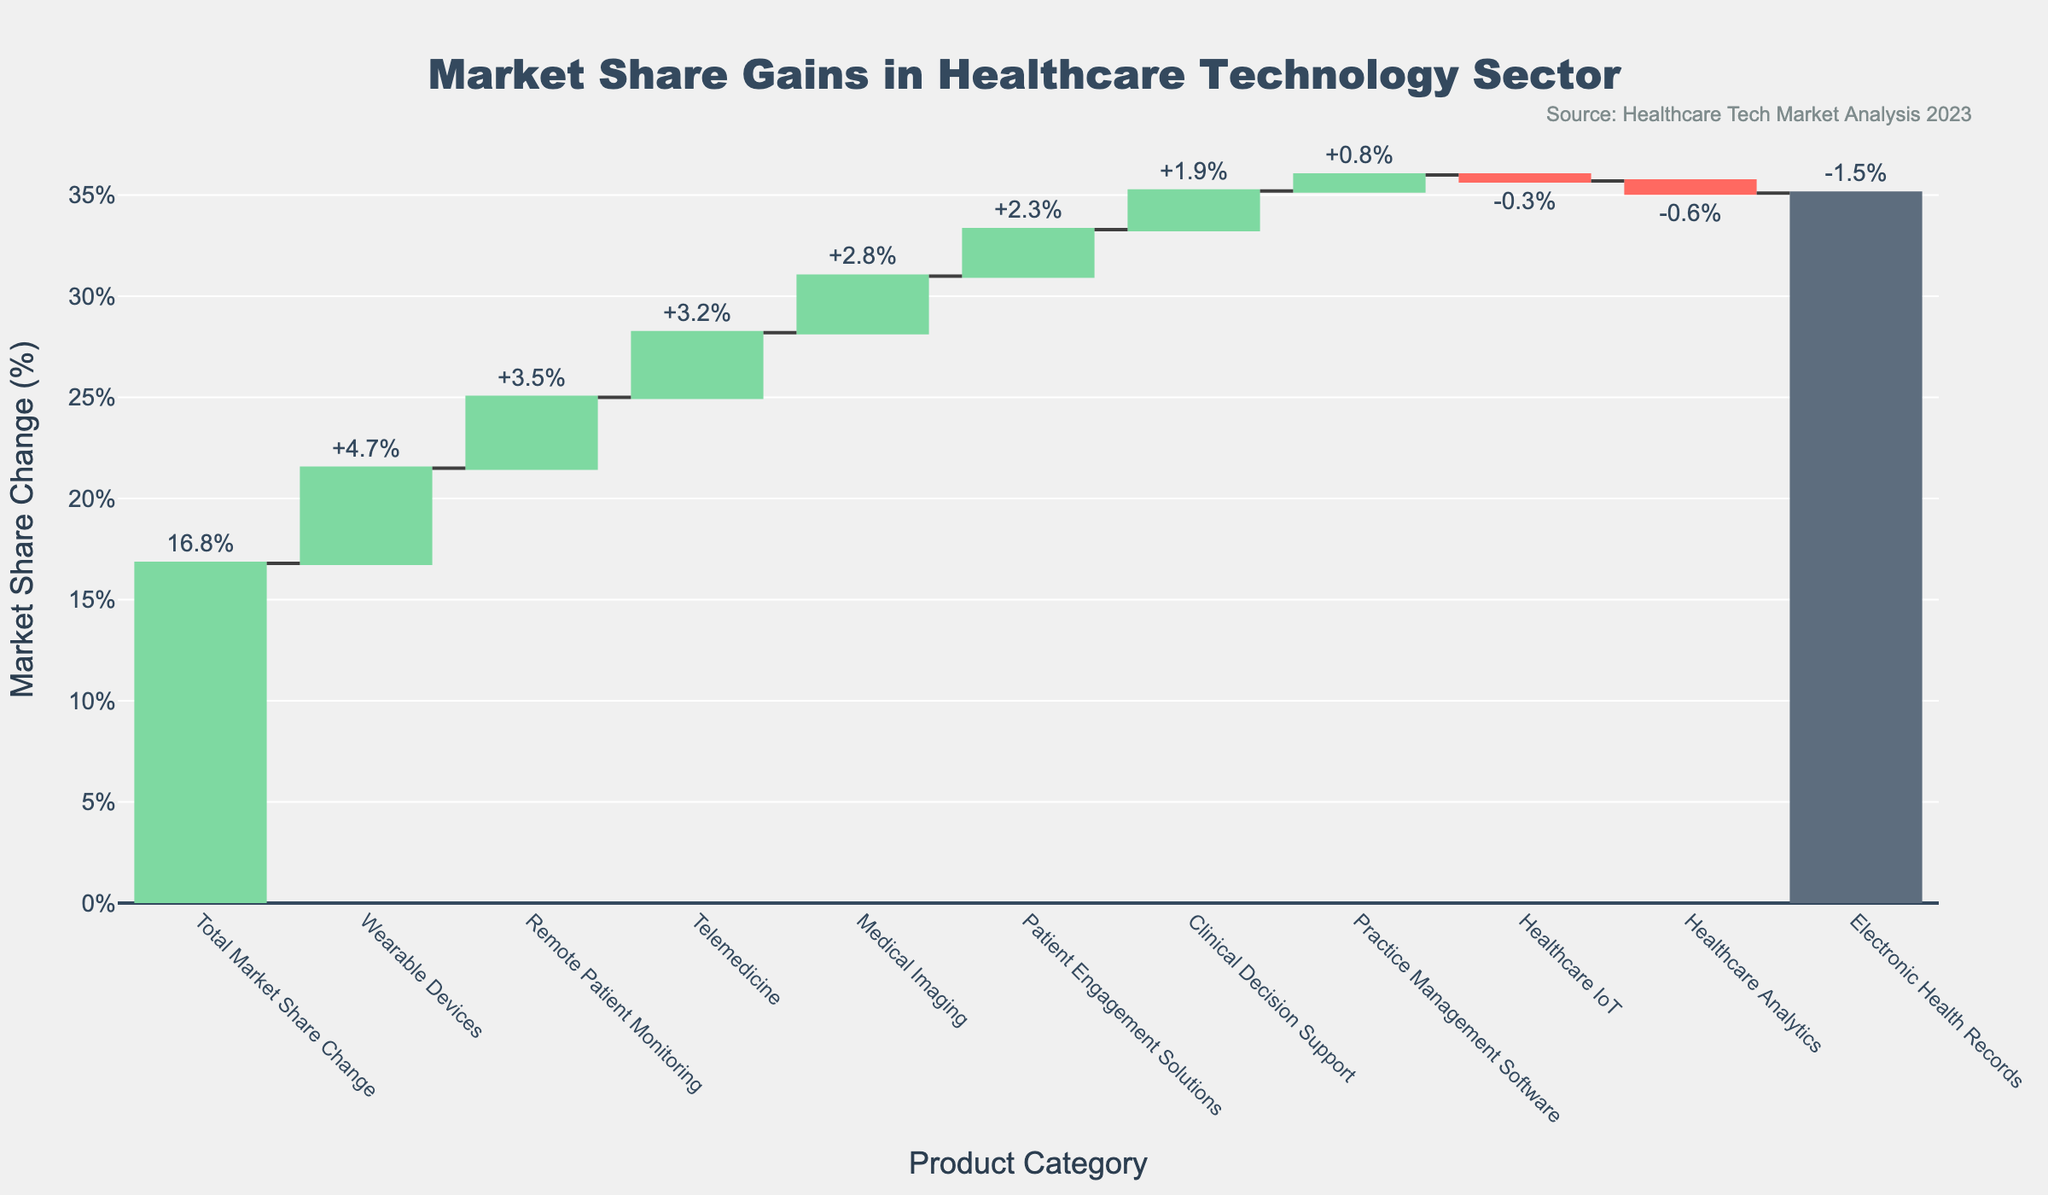What is the total market share change for all product categories combined? The total market share change is explicitly stated as the last bar in the chart.
Answer: 16.8% Which product category experienced the highest gain in market share? By examining the height of the bars labeled with positive market share changes, the tallest bar is for Wearable Devices.
Answer: Wearable Devices How many product categories showed a negative market share change? Count the bars colored in red, which indicate a negative change. There are three such bars: Electronic Health Records, Healthcare Analytics, and Healthcare IoT.
Answer: 3 What is the combined market share change for categories with a negative change? Sum the market share changes of Electronic Health Records (-1.5), Healthcare Analytics (-0.6), and Healthcare IoT (-0.3). (-1.5) + (-0.6) + (-0.3) = -2.4.
Answer: -2.4% What is the difference in market share change between Medical Imaging and Telemedicine? The market share change for Medical Imaging is +2.8, and for Telemedicine, it is +3.2. The difference is 3.2 - 2.8 = 0.4.
Answer: 0.4% Which product category contributed the most to the overall market share gain? Wearable Devices contributed the most, with a market share change of +4.7%, the largest single positive change among the categories.
Answer: Wearable Devices List the product categories that had a market share change above the average increase for all positive changes. First, calculate the average of positive changes: (+3.2 + +2.8 + +4.7 + +1.9 + +2.3 + +3.5 + +0.8)/7 = 19.2/7 ≈ 2.74. The categories with changes above 2.74% are Telemedicine, Medical Imaging, Wearable Devices, and Remote Patient Monitoring.
Answer: Telemedicine, Medical Imaging, Wearable Devices, Remote Patient Monitoring How much more market share did Patient Engagement Solutions gain compared to Clinical Decision Support? Patient Engagement Solutions gained +2.3%, while Clinical Decision Support gained +1.9%. The difference is 2.3 - 1.9 = 0.4.
Answer: 0.4% What can you infer about the healthcare IoT market based on this chart? The bar for Healthcare IoT shows a slight negative market share change of -0.3%, indicating it lost some market share.
Answer: Lost some market share Which category contributed least positively to the market share gain? The smallest positive market share change is +0.8% for Practice Management Software.
Answer: Practice Management Software 